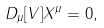<formula> <loc_0><loc_0><loc_500><loc_500>D _ { \mu } [ V ] X ^ { \mu } = 0 ,</formula> 